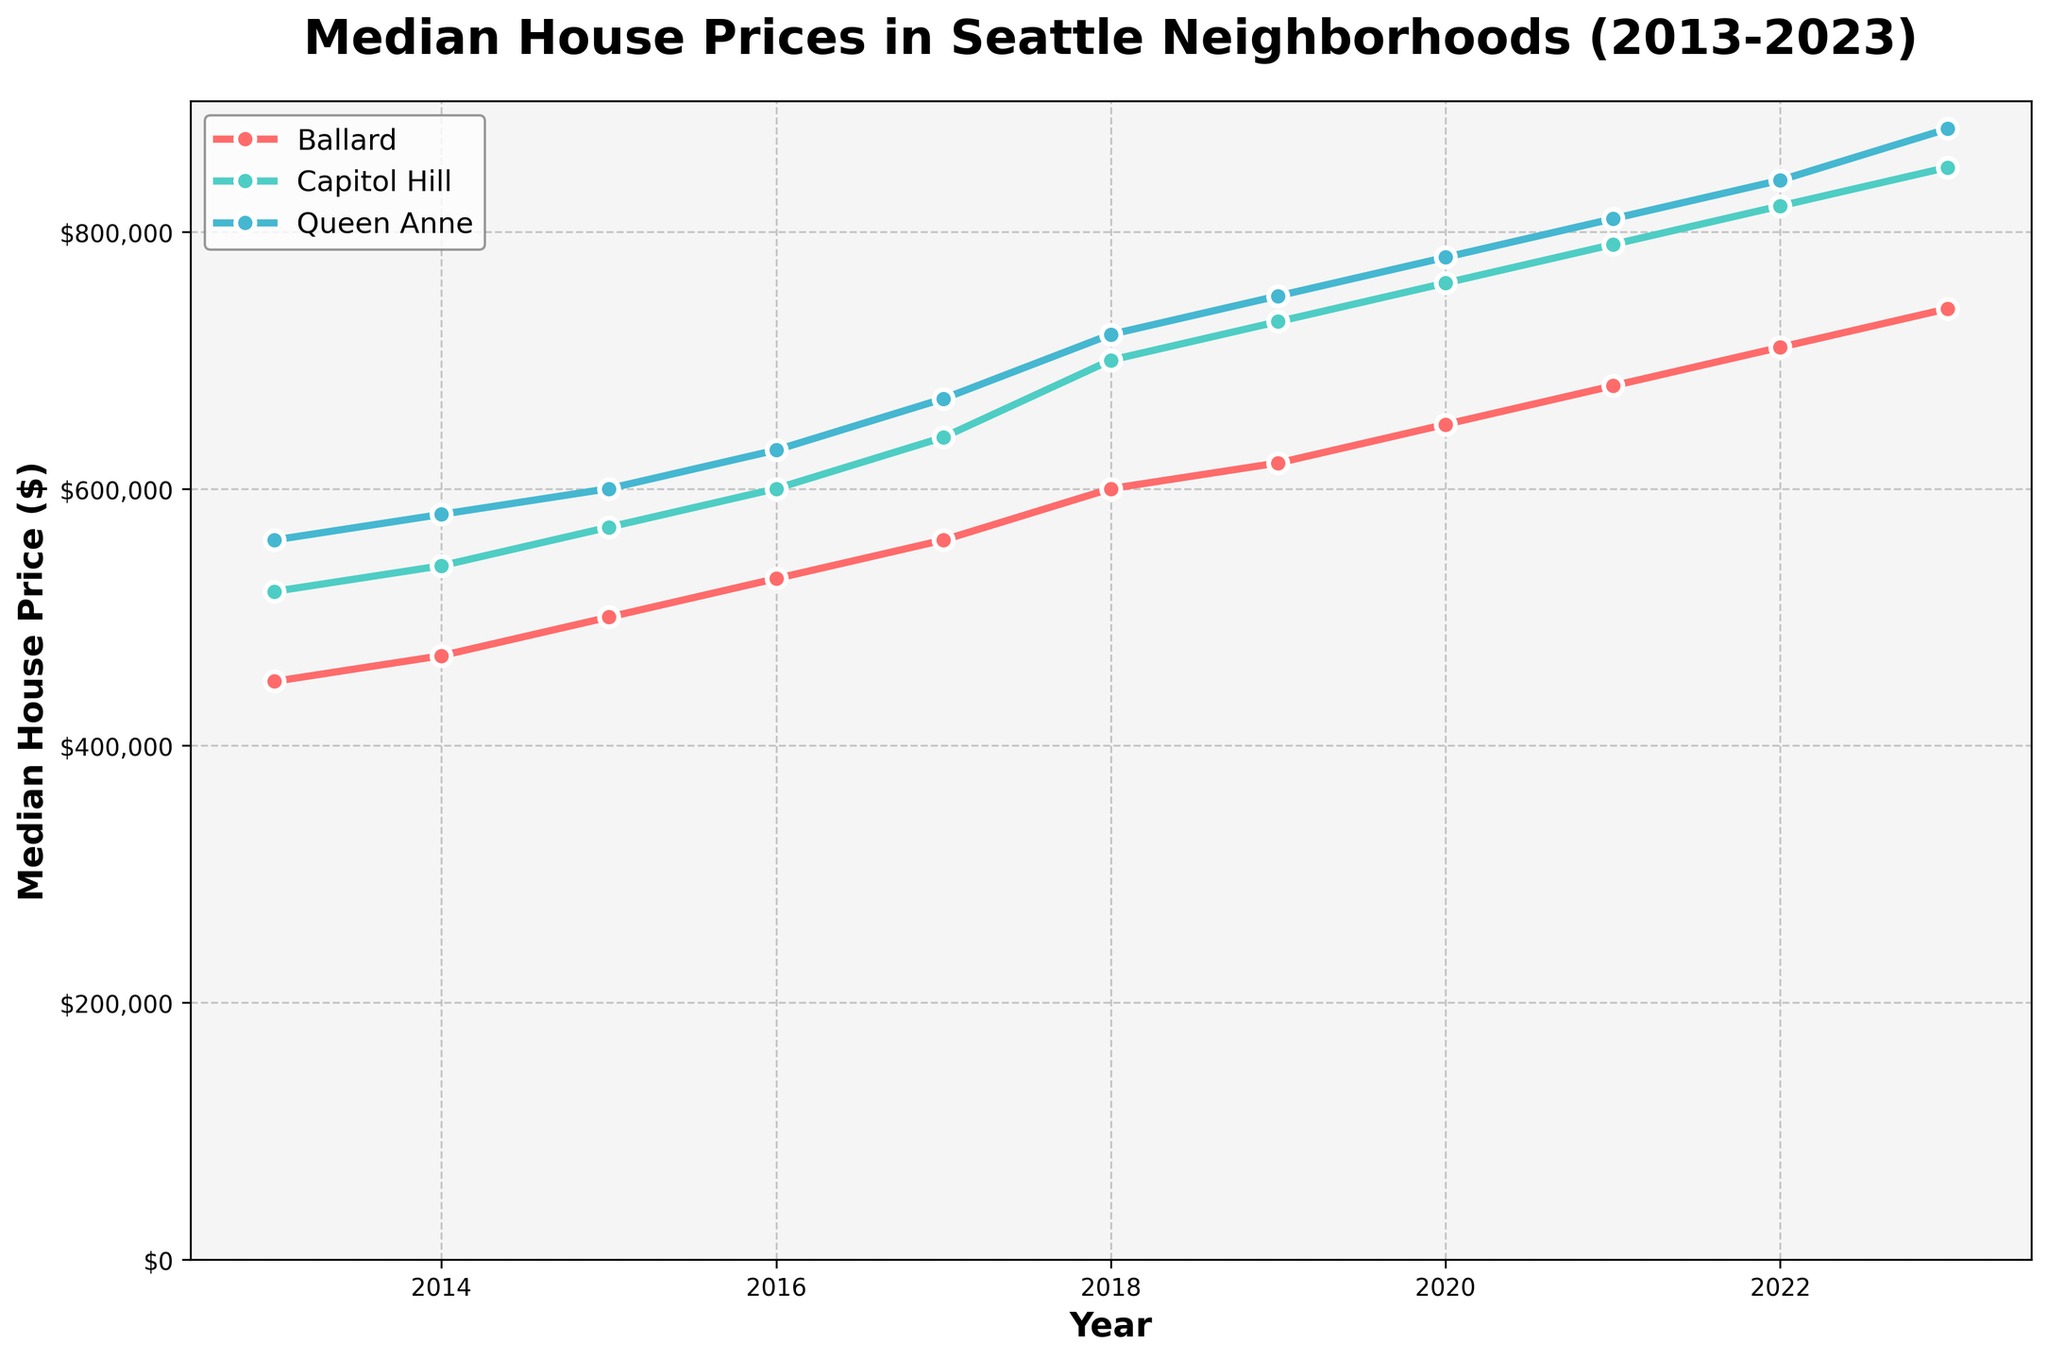What is the title of the figure? The title is usually located at the top of the figure and provides an overview of the data being presented. In this case, the title informs viewers that the plot is about median house prices in specific Seattle neighborhoods over a specified period.
Answer: Median House Prices in Seattle Neighborhoods (2013-2023) Which neighborhood had the highest median house price in 2023? To determine this, check the data points for each neighborhood corresponding to the year 2023. Compare the median house prices for Ballard, Capitol Hill, and Queen Anne in 2023.
Answer: Queen Anne How did Ballard's median house price change from 2013 to 2023? Identify the data points for Ballard in 2013 and 2023. Subtract the median house price in 2013 from the median house price in 2023 to find the change.
Answer: Increased by $290,000 What is the overall trend of house prices in Capitol Hill over the decade? Observe the progression of data points for Capitol Hill from 2013 to 2023. Notice whether the trend is upward, downward, or stable.
Answer: Upward Compare the rate of increase in house prices between Capitol Hill and Ballard from 2013 to 2023. Calculate the difference in median house prices for both neighborhoods between 2013 and 2023. Compare these differences to assess which had a higher rate of increase.
Answer: Capitol Hill increased more In which year did Queen Anne's median house price reach $700,000? Look at the data points for Queen Anne and identify the year when the median house price first crosses $700,000.
Answer: 2018 How much did the median house price in Ballard increase from 2017 to 2018? Find the median house prices for Ballard in 2017 and 2018. Subtract the 2017 value from the 2018 value to find the increase.
Answer: $40,000 Which neighborhood showed the most consistent increase in median house prices over the 10 years? Analyze the trends for Ballard, Capitol Hill, and Queen Anne. Determine which neighborhood's data points show a steady upward trend without major fluctuations.
Answer: All neighborhoods show steady increases, but Capitol Hill shows a more linear increase What was the median house price in Capitol Hill in 2020? Locate the data point for Capitol Hill corresponding to the year 2020. The price can be read directly from the plot.
Answer: $760,000 Between which consecutive years did Queen Anne experience the highest increase in median house price? Calculate the differences in median house prices between consecutive years for Queen Anne. Identify the pair of years with the highest increase.
Answer: 2017 to 2018 